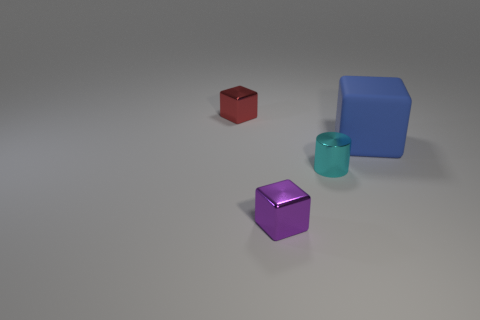Is the red object made of the same material as the blue thing?
Offer a very short reply. No. What is the shape of the big thing behind the small cube that is to the right of the red object that is behind the small cyan shiny object?
Provide a succinct answer. Cube. What is the material of the tiny object that is both to the left of the metallic cylinder and in front of the blue object?
Offer a very short reply. Metal. What is the color of the shiny block that is right of the small block behind the tiny block to the right of the red block?
Provide a short and direct response. Purple. What number of blue things are either big matte objects or small cubes?
Give a very brief answer. 1. What number of other things are the same size as the cyan metallic cylinder?
Your answer should be very brief. 2. How many tiny red cylinders are there?
Make the answer very short. 0. Is there anything else that is the same shape as the small red thing?
Your response must be concise. Yes. Is the material of the small object that is behind the big block the same as the small cube in front of the red thing?
Your answer should be very brief. Yes. What material is the tiny red cube?
Make the answer very short. Metal. 